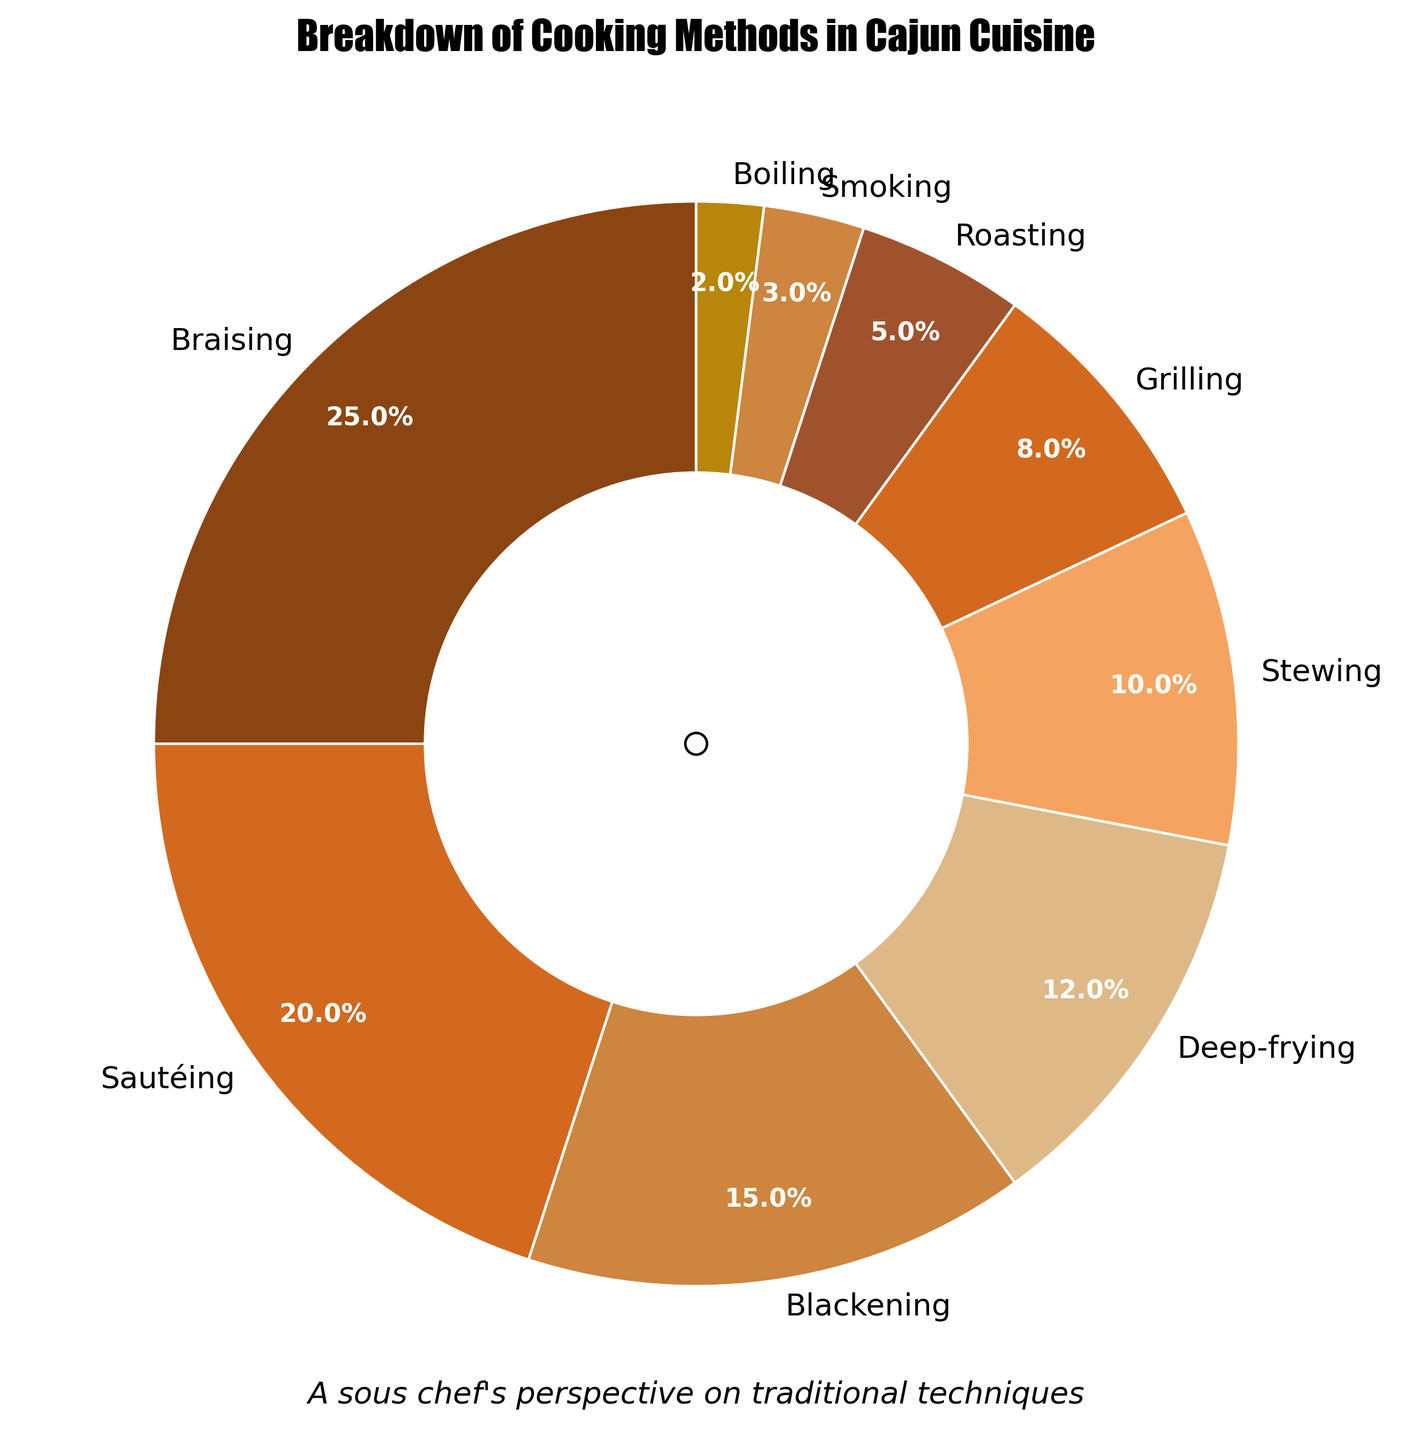What is the most common cooking method employed in traditional Cajun dishes? Look at the segment with the largest percentage in the pie chart. It is labeled and colored uniquely.
Answer: Braising What is the least common cooking method employed in the chart? Look at the segment with the smallest percentage in the pie chart. It is labeled and colored uniquely.
Answer: Boiling What is the combined percentage of Grilling and Smoking? Find the percentages for Grilling and Smoking (8% and 3%), then add them: 8% + 3% = 11%.
Answer: 11% Which cooking method is employed more frequently: Blackening or Stewing? Compare the percentages for Blackening (15%) and Stewing (10%).
Answer: Blackening What is the total percentage for Braising, Sautéing, and Blackening combined? Sum the percentages for Braising (25%), Sautéing (20%), and Blackening (15%): 25% + 20% + 15% = 60%.
Answer: 60% If you combine Stewing and Roasting, does their total percentage surpass Deep-frying? Sum the percentages for Stewing (10%) and Roasting (5%): 10% + 5% = 15%. Compare this with Deep-frying (12%).
Answer: Yes Which segment is colored in the darkest shade and which cooking method does it represent? Visually identify the darkest-colored segment in the pie chart and read its label.
Answer: Braising What is the difference in percentage between Sautéing and Deep-frying methods? Subtract the percentage of Deep-frying (12%) from Sautéing (20%): 20% - 12% = 8%.
Answer: 8% What are the top three cooking methods by usage percentage? Identify the three largest segments in the pie chart and read their labels.
Answer: Braising, Sautéing, Blackening By how much does the percentage of Braising exceed Grilling? Subtract the percentage for Grilling (8%) from Braising (25%): 25% - 8% = 17%.
Answer: 17% 